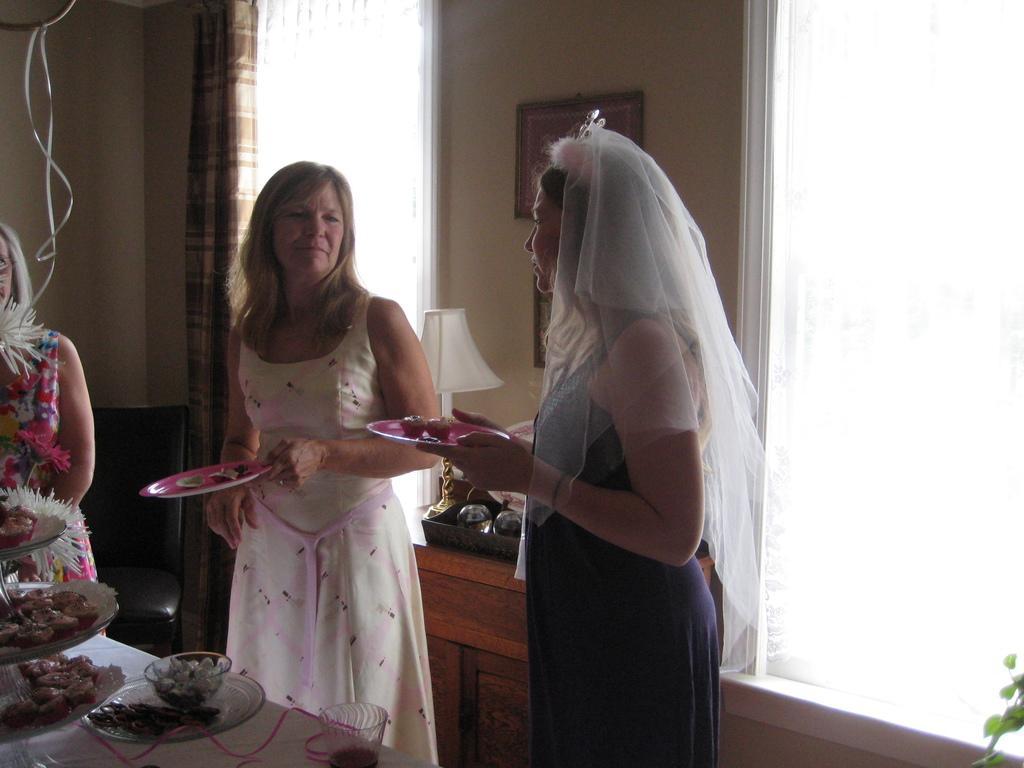Could you give a brief overview of what you see in this image? In this image there are two people holding the plates with food items in it. Beside them there is another person. In front of them there is a table. On top of it there are a food items on the plates and a bowl. There is a glass on the table. Behind them there is a mirror. Through a mirror, we can see the photo frames on the wall. In front of the mirror there is a bed lamp and there are some objects. On the right side of the image there is a plant. There are curtains. In the background of the image there is a wall. In front of the wall there is a wall. 